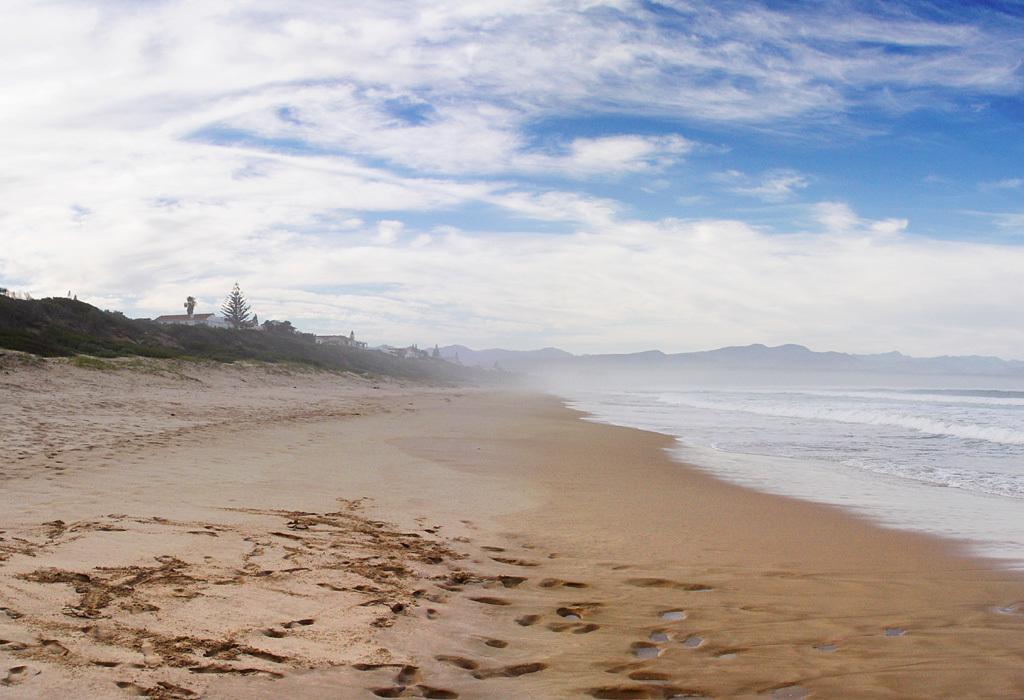What type of natural environment is depicted in the image? The image features trees, water, mountains, and sand, which suggests a natural landscape. Can you describe the water in the image? There is water visible in the image, but its specific characteristics are not mentioned in the facts. What is the color of the sky in the image? The sky is blue and white in color. What type of curve can be seen in the image? There is no curve mentioned or visible in the image. Can you hear the sound of the zephyr in the image? The image is a visual representation, and there is no mention of sound or a zephyr in the provided facts. 